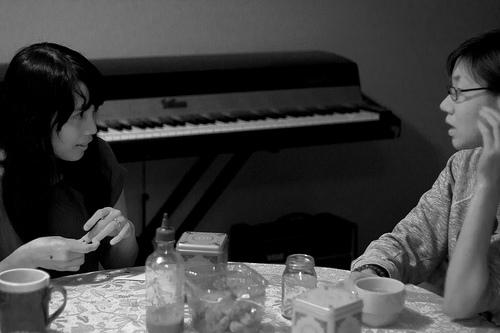Question: how does the picture look?
Choices:
A. Blurred.
B. Dark.
C. Good.
D. Clear.
Answer with the letter. Answer: D Question: where is the piano?
Choices:
A. In background.
B. On stage.
C. Recording studio.
D. Living room.
Answer with the letter. Answer: A Question: why is food on the table?
Choices:
A. To put away.
B. To take to neighbor.
C. For party.
D. Meal time.
Answer with the letter. Answer: D Question: what is one of them wearing?
Choices:
A. Boots.
B. A wig.
C. Glasses.
D. Necklace.
Answer with the letter. Answer: C Question: what type of photo is this?
Choices:
A. Black and white.
B. Serpia.
C. Color.
D. Digital.
Answer with the letter. Answer: A Question: who is sitting at the table?
Choices:
A. Males.
B. Children.
C. Females.
D. Guests.
Answer with the letter. Answer: C 